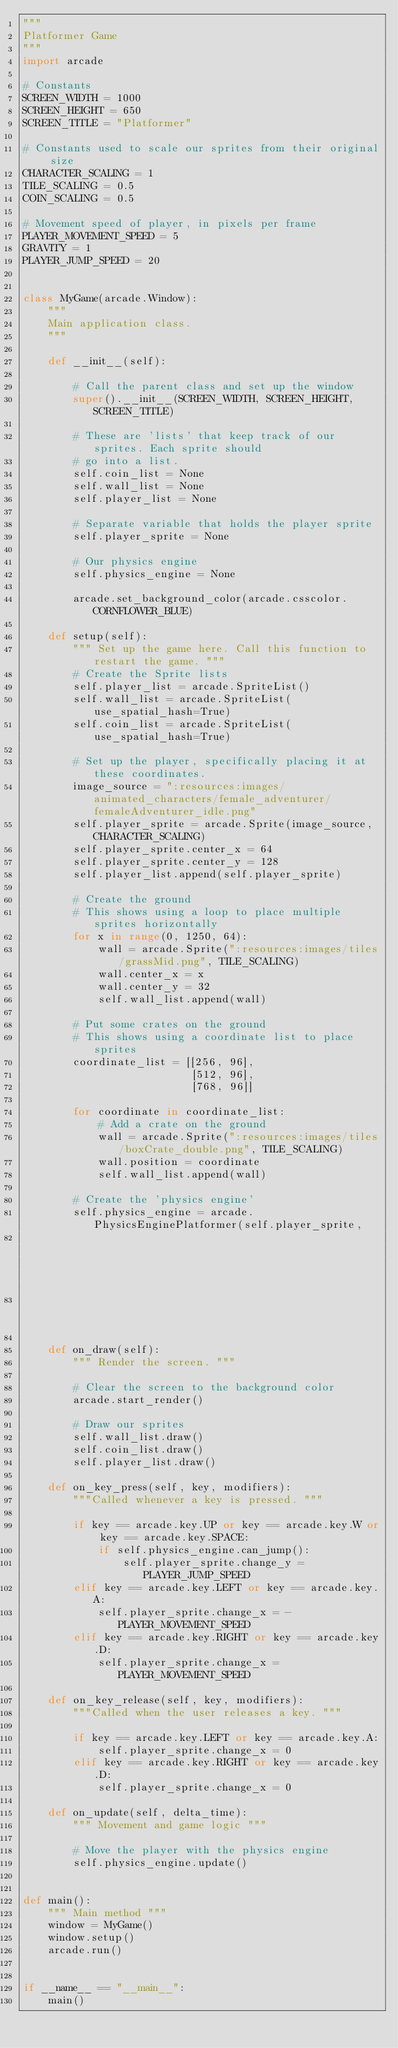Convert code to text. <code><loc_0><loc_0><loc_500><loc_500><_Python_>"""
Platformer Game
"""
import arcade

# Constants
SCREEN_WIDTH = 1000
SCREEN_HEIGHT = 650
SCREEN_TITLE = "Platformer"

# Constants used to scale our sprites from their original size
CHARACTER_SCALING = 1
TILE_SCALING = 0.5
COIN_SCALING = 0.5

# Movement speed of player, in pixels per frame
PLAYER_MOVEMENT_SPEED = 5
GRAVITY = 1
PLAYER_JUMP_SPEED = 20


class MyGame(arcade.Window):
    """
    Main application class.
    """

    def __init__(self):

        # Call the parent class and set up the window
        super().__init__(SCREEN_WIDTH, SCREEN_HEIGHT, SCREEN_TITLE)

        # These are 'lists' that keep track of our sprites. Each sprite should
        # go into a list.
        self.coin_list = None
        self.wall_list = None
        self.player_list = None

        # Separate variable that holds the player sprite
        self.player_sprite = None

        # Our physics engine
        self.physics_engine = None

        arcade.set_background_color(arcade.csscolor.CORNFLOWER_BLUE)

    def setup(self):
        """ Set up the game here. Call this function to restart the game. """
        # Create the Sprite lists
        self.player_list = arcade.SpriteList()
        self.wall_list = arcade.SpriteList(use_spatial_hash=True)
        self.coin_list = arcade.SpriteList(use_spatial_hash=True)

        # Set up the player, specifically placing it at these coordinates.
        image_source = ":resources:images/animated_characters/female_adventurer/femaleAdventurer_idle.png"
        self.player_sprite = arcade.Sprite(image_source, CHARACTER_SCALING)
        self.player_sprite.center_x = 64
        self.player_sprite.center_y = 128
        self.player_list.append(self.player_sprite)

        # Create the ground
        # This shows using a loop to place multiple sprites horizontally
        for x in range(0, 1250, 64):
            wall = arcade.Sprite(":resources:images/tiles/grassMid.png", TILE_SCALING)
            wall.center_x = x
            wall.center_y = 32
            self.wall_list.append(wall)

        # Put some crates on the ground
        # This shows using a coordinate list to place sprites
        coordinate_list = [[256, 96],
                           [512, 96],
                           [768, 96]]

        for coordinate in coordinate_list:
            # Add a crate on the ground
            wall = arcade.Sprite(":resources:images/tiles/boxCrate_double.png", TILE_SCALING)
            wall.position = coordinate
            self.wall_list.append(wall)

        # Create the 'physics engine'
        self.physics_engine = arcade.PhysicsEnginePlatformer(self.player_sprite,
                                                             self.wall_list,
                                                             GRAVITY)

    def on_draw(self):
        """ Render the screen. """

        # Clear the screen to the background color
        arcade.start_render()

        # Draw our sprites
        self.wall_list.draw()
        self.coin_list.draw()
        self.player_list.draw()

    def on_key_press(self, key, modifiers):
        """Called whenever a key is pressed. """

        if key == arcade.key.UP or key == arcade.key.W or key == arcade.key.SPACE:
            if self.physics_engine.can_jump():
                self.player_sprite.change_y = PLAYER_JUMP_SPEED
        elif key == arcade.key.LEFT or key == arcade.key.A:
            self.player_sprite.change_x = -PLAYER_MOVEMENT_SPEED
        elif key == arcade.key.RIGHT or key == arcade.key.D:
            self.player_sprite.change_x = PLAYER_MOVEMENT_SPEED

    def on_key_release(self, key, modifiers):
        """Called when the user releases a key. """

        if key == arcade.key.LEFT or key == arcade.key.A:
            self.player_sprite.change_x = 0
        elif key == arcade.key.RIGHT or key == arcade.key.D:
            self.player_sprite.change_x = 0

    def on_update(self, delta_time):
        """ Movement and game logic """

        # Move the player with the physics engine
        self.physics_engine.update()


def main():
    """ Main method """
    window = MyGame()
    window.setup()
    arcade.run()


if __name__ == "__main__":
    main()</code> 